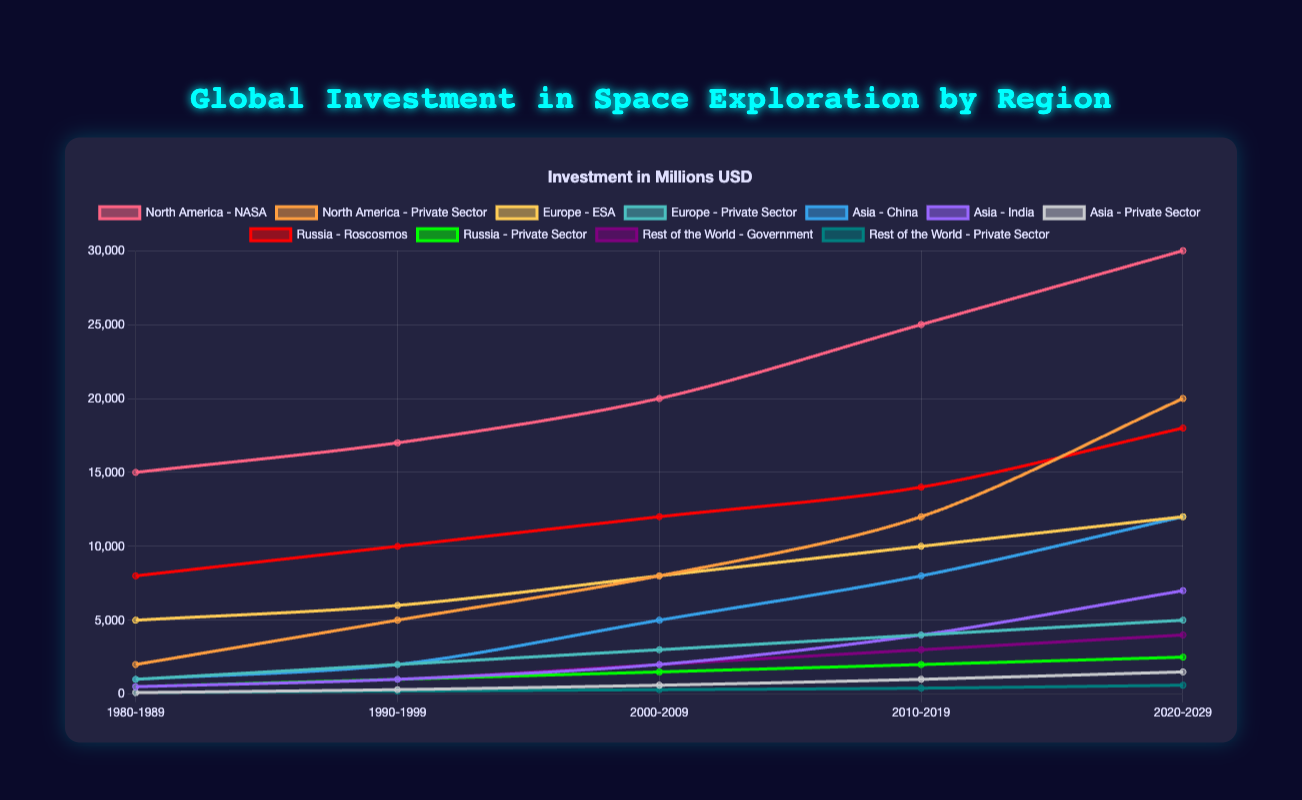what is the title of the chart? The title is displayed at the top of the chart in blue text with a shadow effect. It reads "Global Investment in Space Exploration by Region."
Answer: Global Investment in Space Exploration by Region How many time periods are shown on the chart? The x-axis of the chart displays the time periods. There are five distinct time periods listed: 1980-1989, 1990-1999, 2000-2009, 2010-2019, and 2020-2029.
Answer: 5 Which sector in North America has shown the largest increase in investment from 1980 to 2029? To determine this, compare the investment values of both sectors (NASA and Private Sector) in 1980 and 2029. NASA increased from 15,000 to 30,000, while the Private Sector increased from 2,000 to 20,000. The Private Sector shows a larger increase.
Answer: Private Sector What is the total investment for Europe's ESA and Private Sector combined in the time period 2010-2019? ESA's investment is 10,000, and the Private Sector's investment is 4,000 for this period. Add these values to get the total investment: 10,000 + 4,000 = 14,000.
Answer: 14,000 By how much has China's investment increased from the time period 1980-1989 to 2020-2029? China's investment was 1,000 in 1980-1989 and increased to 12,000 in 2020-2029. The difference is 12,000 - 1,000 = 11,000.
Answer: 11,000 Comparing the government investments in the Rest of the World to India's investment, which one had higher investment in 1990-1999? The Rest of the World government's investment is 1,000, while India's investment is also 1,000 for the 1990-1999 period. They are equal.
Answer: They are equal Which region has shown a consistent increase in investment in all sectors over all time periods? Examining each region and their sectors, North America's NASA and Private Sector, as well as Europe's ESA and Private Sector, show consistent increases over all time periods. Both of these regions display a consistent upward trend across all sectors.
Answer: North America, Europe What is the difference in investment between North America's NASA and Russia's Roscosmos in the time period 2020-2029? In 2020-2029, NASA's investment is 30,000, and Roscosmos's investment is 18,000. The difference is 30,000 - 18,000 = 12,000.
Answer: 12,000 Which sector shows the smallest investment in the time period 2000-2009? Reviewing the data, Asia’s Private Sector has the smallest investment of 600 in the 2000-2009 period.
Answer: Asia's Private Sector How much more did the European Private Sector invest in space exploration in 2000-2009 compared to Asia's Private Sector in the same period? Europe’s Private Sector invested 3,000, while Asia’s Private Sector invested 600 in 2000-2009. The difference is 3,000 - 600 = 2,400.
Answer: 2,400 